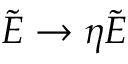<formula> <loc_0><loc_0><loc_500><loc_500>\tilde { E } \rightarrow \eta \tilde { E }</formula> 